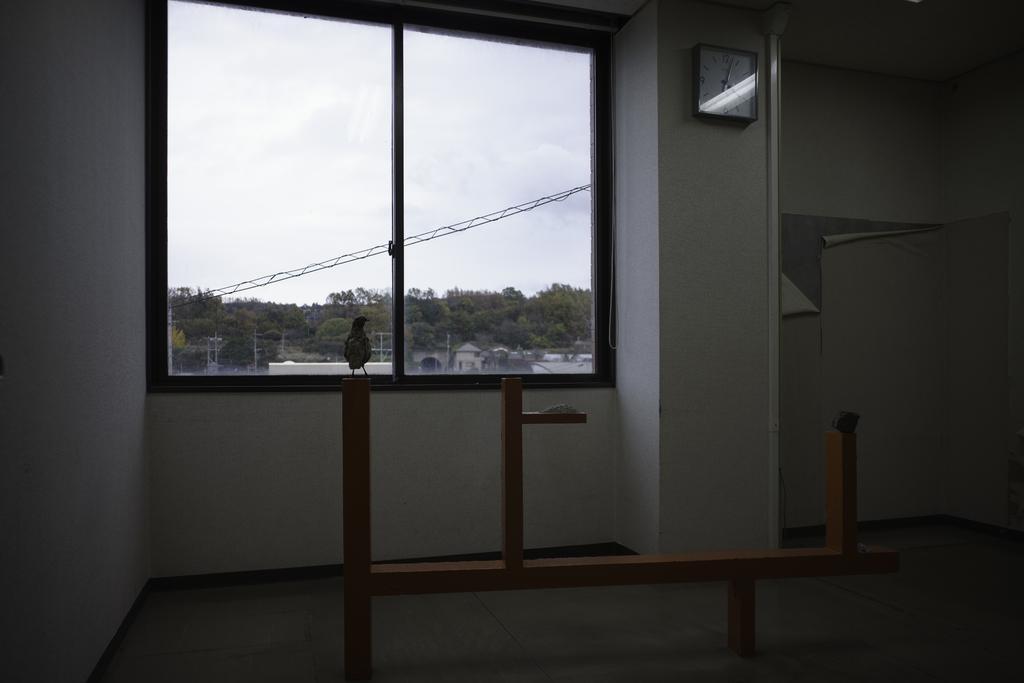Please provide a concise description of this image. In the foreground of this image, on a wooden structure there is a bird. In the background, there is a wall, clock and through the window we can see trees, cables, buildings and the sky. 